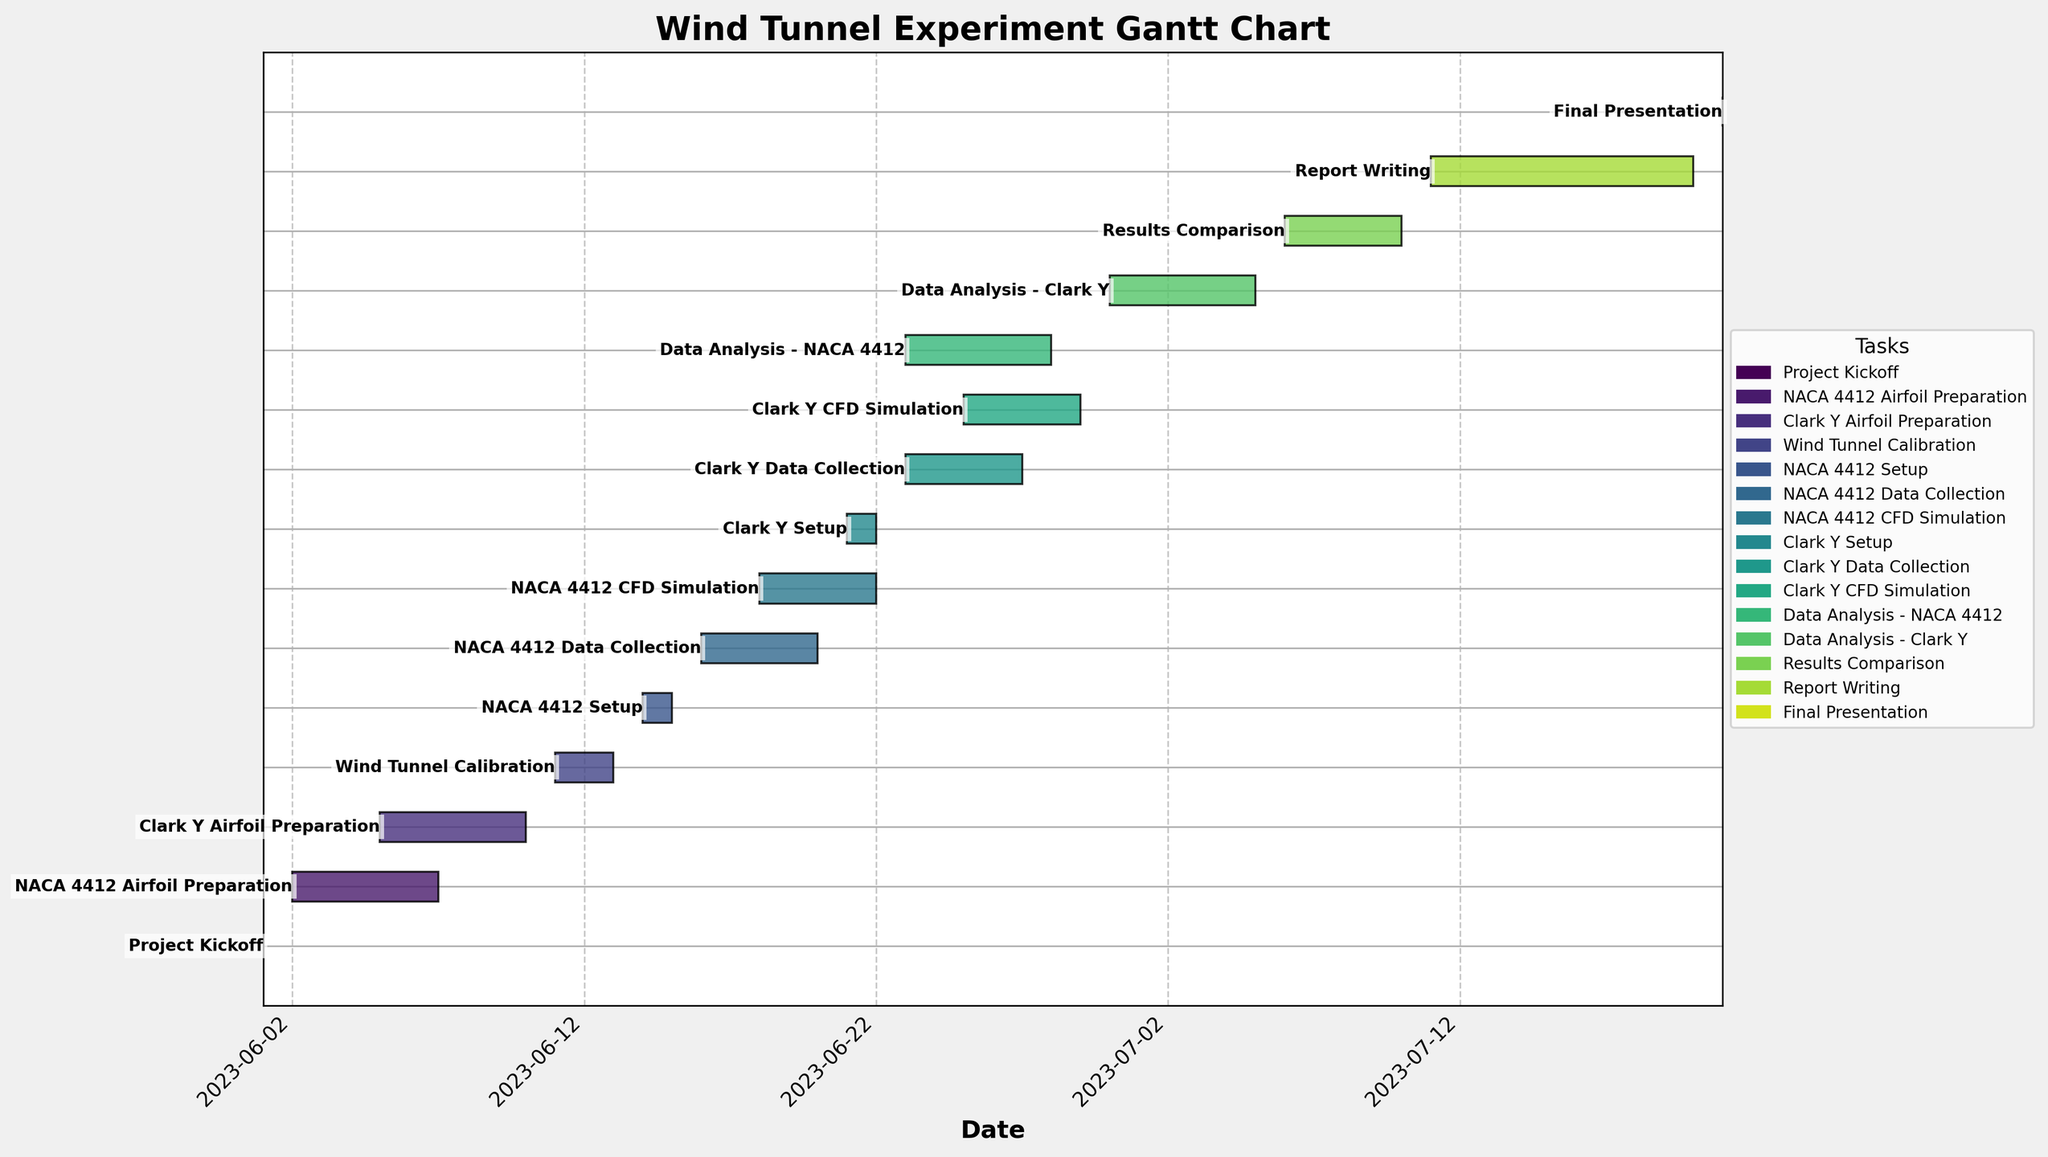Which task starts immediately after the wind tunnel calibration? The wind tunnel calibration ends on 2023-06-13, and the next task starting on 2023-06-14 is the NACA 4412 Setup.
Answer: NACA 4412 Setup What is the title of the Gantt chart? The title is "Wind Tunnel Experiment Gantt Chart" as shown at the top of the chart.
Answer: Wind Tunnel Experiment Gantt Chart How many tasks are shown in the chart? The chart lists 15 distinct tasks, each represented by a horizontal bar.
Answer: 15 Which airfoil's data collection phase starts first? The data collection phase for the NACA 4412 starts on 2023-06-16, which is before the Clark Y data collection starting on 2023-06-23.
Answer: NACA 4412 What is the color pattern used in the chart for different tasks? The tasks are colored using varying shades of a single color palette, likely ranging from lighter to darker shades based on the sequence in the data.
Answer: Various shades of a single palette How long is the Clark Y CFD Simulation phase in days, and how does it compare to the NACA 4412 CFD Simulation phase? Clark Y CFD Simulation runs from 2023-06-25 to 2023-06-29, spanning 5 days. NACA 4412 CFD Simulation runs from 2023-06-18 to 2023-06-22, also spanning 5 days. Both phases are of equal duration.
Answer: Both 5 days Which partial tasks are accomplished concurrently with NACA 4412 Data Collection? NACA 4412 Data Collection (2023-06-16 to 2023-06-20) overlaps with NACA 4412 CFD Simulation (2023-06-18 to 2023-06-22).
Answer: NACA 4412 CFD Simulation When do the preparation phases for both airfoils overlap? The preparation for NACA 4412 (2023-06-02 to 2023-06-07) overlaps with Clark Y preparation (2023-06-05 to 2023-06-10) from 2023-06-05 to 2023-06-07.
Answer: 2023-06-05 to 2023-06-07 What is the duration of the report writing phase? Report Writing runs from 2023-07-11 to 2023-07-20, which is a span of 10 days.
Answer: 10 days How soon after the final presentation does the data analysis for Clark Y airfoil end? The final presentation is on 2023-07-21, while the data analysis for Clark Y concludes on 2023-07-05. The final presentation follows the data analysis by 16 days.
Answer: 16 days 